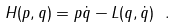<formula> <loc_0><loc_0><loc_500><loc_500>H ( p , q ) = p \dot { q } - L ( q , \dot { q } ) \ .</formula> 